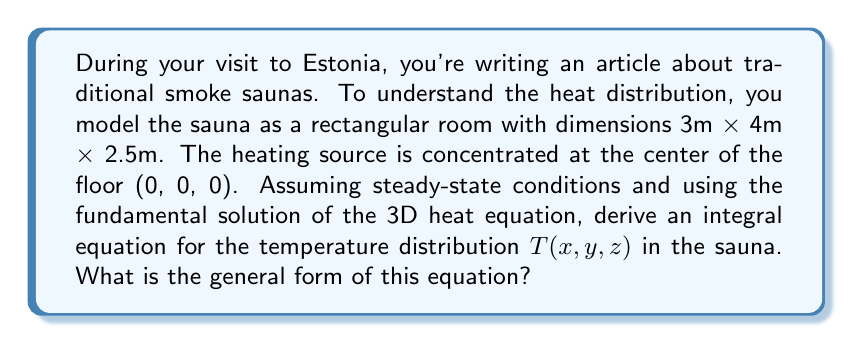Help me with this question. Let's approach this step-by-step:

1) The fundamental solution of the 3D heat equation in steady-state is given by:

   $$G(r) = \frac{1}{4\pi kr}$$

   where $k$ is the thermal conductivity and $r$ is the distance from the source.

2) In our case, $r$ is the distance from any point (x, y, z) to the source at (0, 0, 0):

   $$r = \sqrt{x^2 + y^2 + z^2}$$

3) The heat source can be modeled as a point source with strength $Q$ (in Watts) at (0, 0, 0).

4) The temperature at any point (x, y, z) due to this source is:

   $$T(x,y,z) = \frac{Q}{4\pi k\sqrt{x^2 + y^2 + z^2}}$$

5) However, in a real sauna, heat is not just from a point source but is distributed throughout the room due to reflection and radiation from walls. We can model this using the method of images.

6) We need to consider reflections from all 6 surfaces of the rectangular room. This leads to an infinite series of image sources.

7) The general form of the integral equation for temperature distribution will be:

   $$T(x,y,z) = \frac{Q}{4\pi k} \int\int\int \frac{f(x',y',z')}{\sqrt{(x-x')^2 + (y-y')^2 + (z-z')^2}} dx'dy'dz'$$

   where $f(x',y',z')$ represents the distribution of heat sources including all reflections.

8) The limits of integration will be from -∞ to +∞ for each variable, as we're considering an infinite series of reflections.
Answer: $$T(x,y,z) = \frac{Q}{4\pi k} \int\int\int \frac{f(x',y',z')}{\sqrt{(x-x')^2 + (y-y')^2 + (z-z')^2}} dx'dy'dz'$$ 